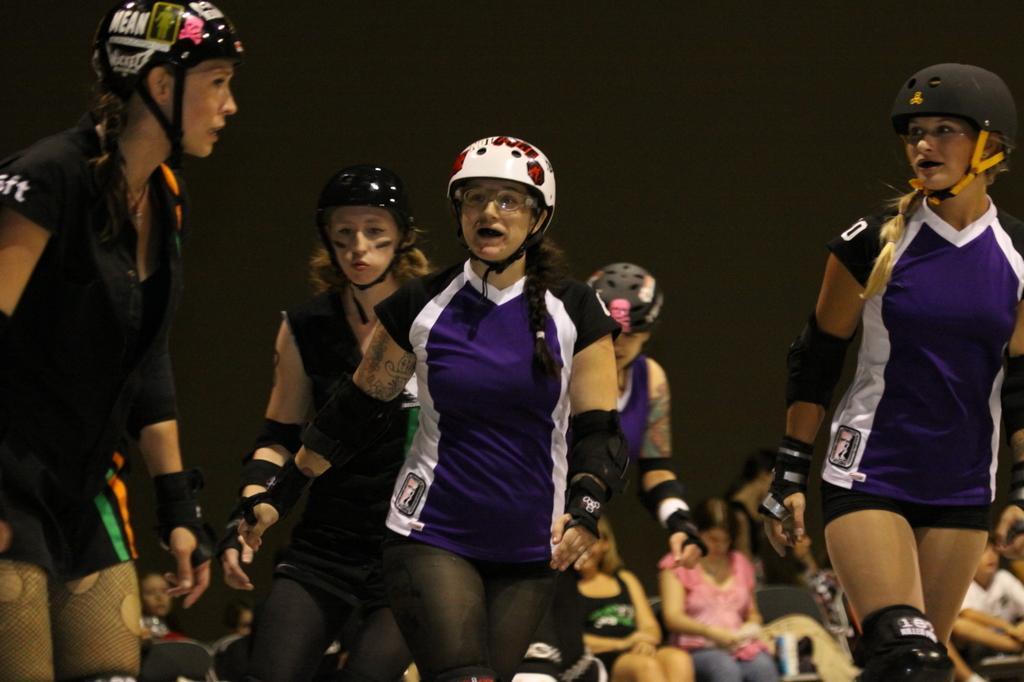Could you give a brief overview of what you see in this image? In this picture we can see a group of people, some people standing, some people are sitting on chairs and some people are wearing helmets and in the background we can see it is dark. 